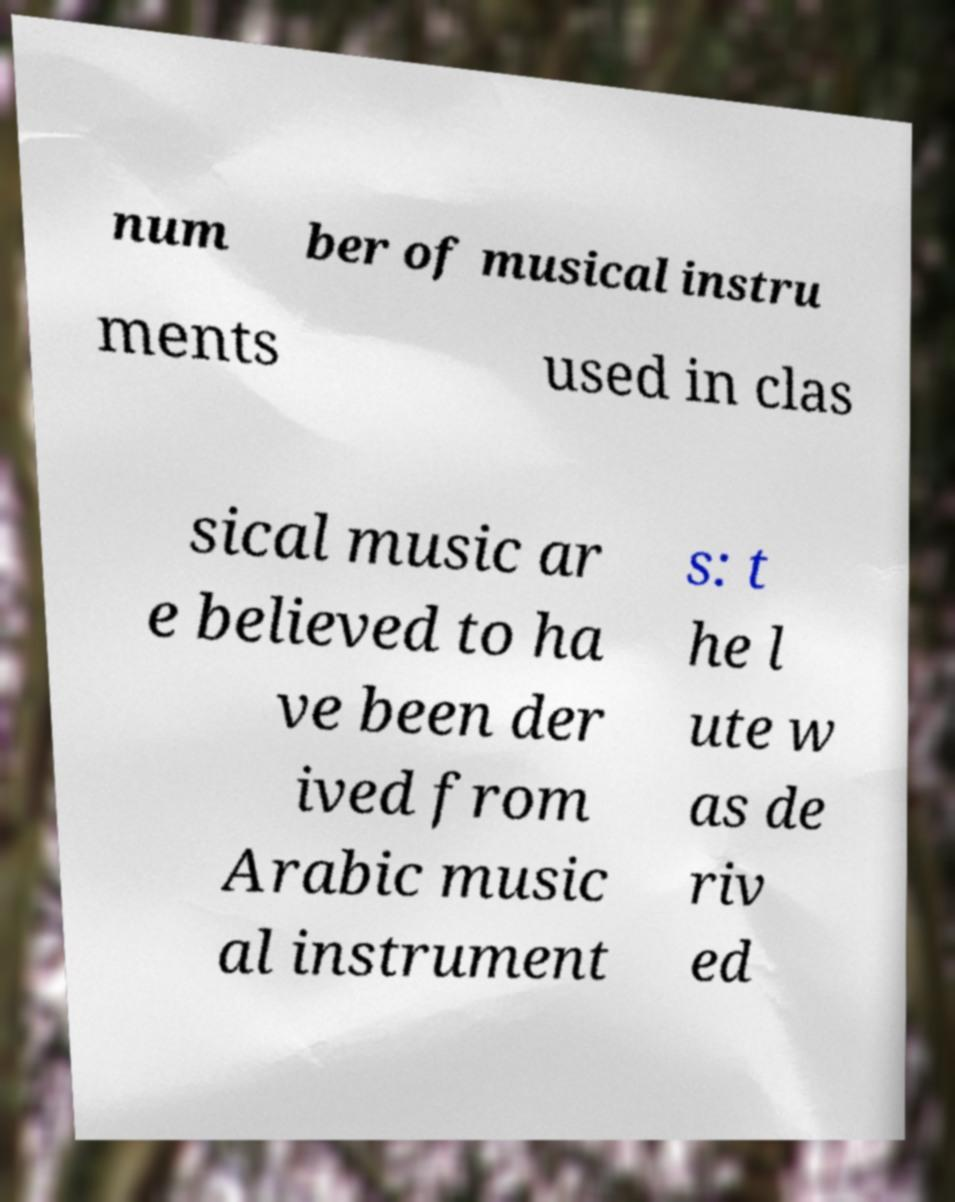I need the written content from this picture converted into text. Can you do that? num ber of musical instru ments used in clas sical music ar e believed to ha ve been der ived from Arabic music al instrument s: t he l ute w as de riv ed 